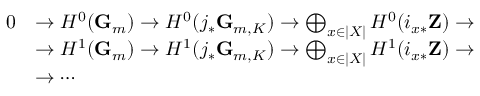<formula> <loc_0><loc_0><loc_500><loc_500>{ \begin{array} { r l } { 0 } & { \to H ^ { 0 } ( G _ { m } ) \to H ^ { 0 } ( j _ { * } G _ { m , K } ) \to \bigoplus _ { x \in | X | } H ^ { 0 } ( i _ { x * } Z ) \to } \\ & { \to H ^ { 1 } ( G _ { m } ) \to H ^ { 1 } ( j _ { * } G _ { m , K } ) \to \bigoplus _ { x \in | X | } H ^ { 1 } ( i _ { x * } Z ) \to } \\ & { \to \cdots } \end{array} }</formula> 